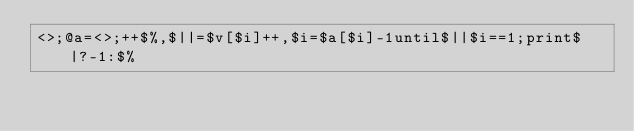Convert code to text. <code><loc_0><loc_0><loc_500><loc_500><_Perl_><>;@a=<>;++$%,$||=$v[$i]++,$i=$a[$i]-1until$||$i==1;print$|?-1:$%</code> 